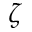Convert formula to latex. <formula><loc_0><loc_0><loc_500><loc_500>\zeta</formula> 